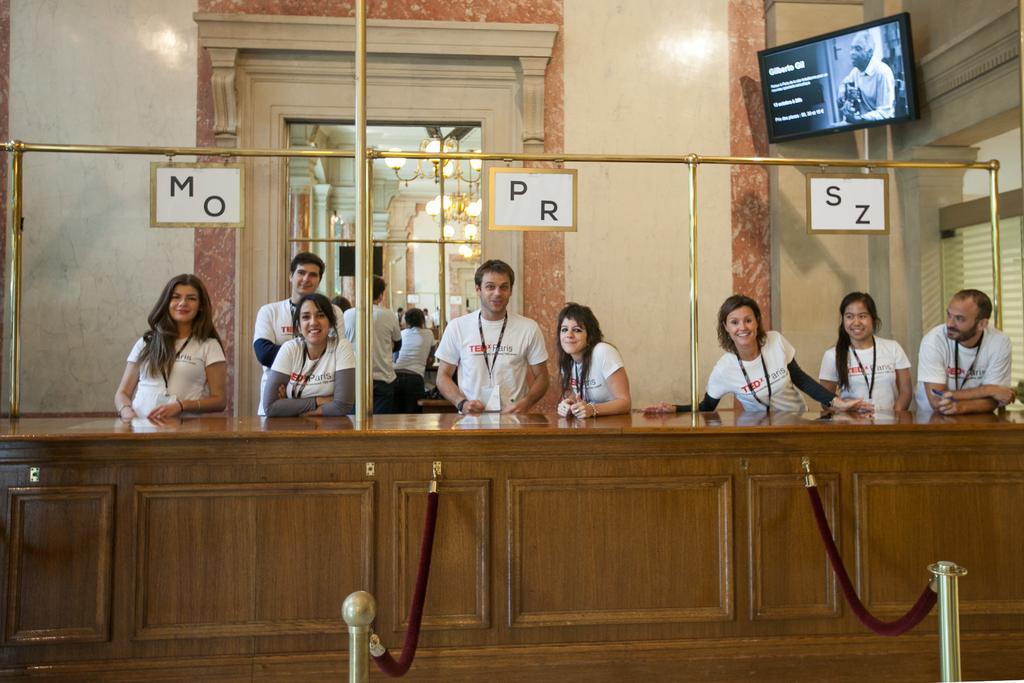Can you describe this image briefly? In this image we can see persons standing on the floor and table is placed in front of them. In the background we can see chandeliers, walls, name boards and a display screen. 